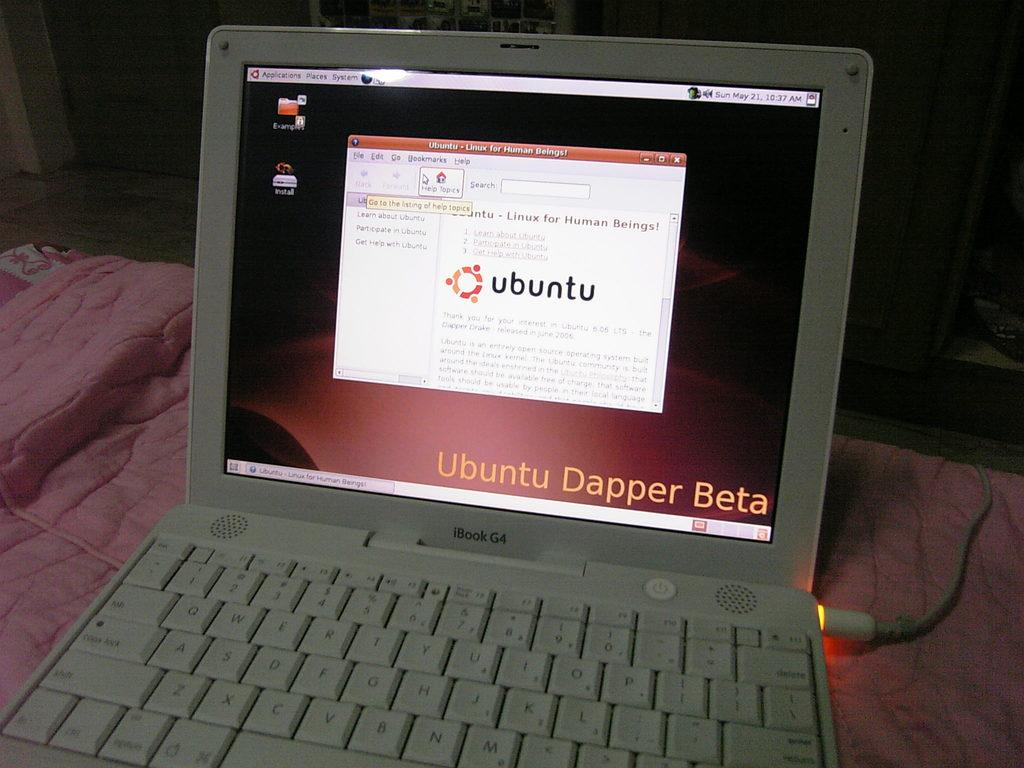<image>
Summarize the visual content of the image. An iBook G4 has a screen open for Ubuntu. 